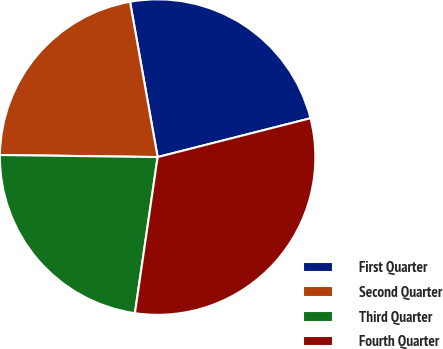<chart> <loc_0><loc_0><loc_500><loc_500><pie_chart><fcel>First Quarter<fcel>Second Quarter<fcel>Third Quarter<fcel>Fourth Quarter<nl><fcel>23.84%<fcel>21.99%<fcel>22.91%<fcel>31.26%<nl></chart> 